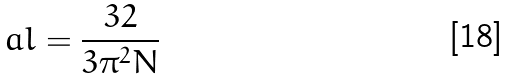Convert formula to latex. <formula><loc_0><loc_0><loc_500><loc_500>\ a l = \frac { 3 2 } { 3 \pi ^ { 2 } N }</formula> 